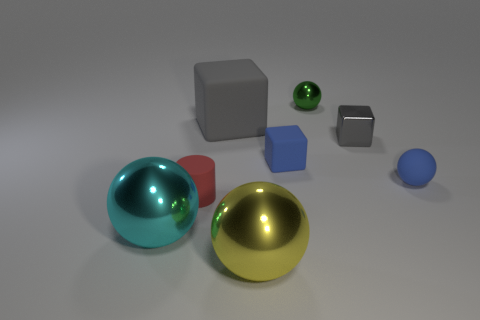What number of small matte objects are the same color as the rubber ball?
Provide a short and direct response. 1. Is there a gray object that has the same size as the blue ball?
Your answer should be compact. Yes. There is a gray cube that is the same size as the yellow object; what is its material?
Provide a succinct answer. Rubber. There is a metallic cube; is it the same size as the matte ball that is to the right of the yellow object?
Give a very brief answer. Yes. There is a large object behind the big cyan metal ball; what is it made of?
Your response must be concise. Rubber. Are there the same number of yellow shiny spheres that are in front of the gray metal object and large yellow metallic balls?
Offer a terse response. Yes. Does the cyan thing have the same size as the yellow metal ball?
Ensure brevity in your answer.  Yes. There is a thing that is in front of the large metal ball that is left of the big gray rubber thing; is there a tiny red cylinder that is behind it?
Offer a terse response. Yes. There is a tiny gray object that is the same shape as the large rubber thing; what is it made of?
Give a very brief answer. Metal. How many large rubber things are in front of the matte object that is in front of the blue sphere?
Offer a very short reply. 0. 